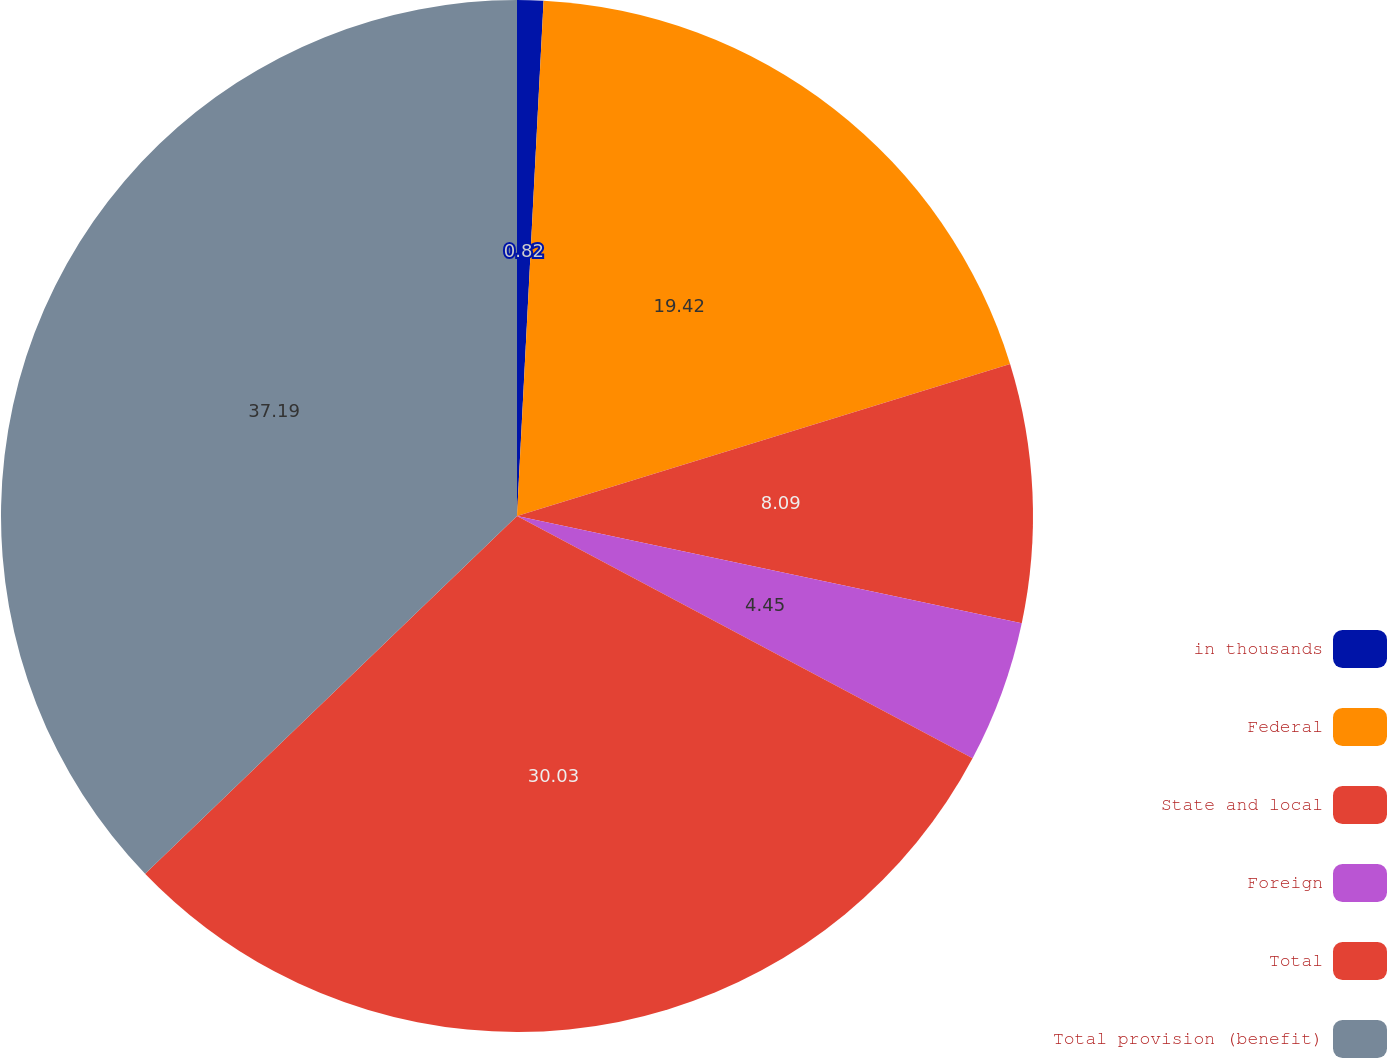<chart> <loc_0><loc_0><loc_500><loc_500><pie_chart><fcel>in thousands<fcel>Federal<fcel>State and local<fcel>Foreign<fcel>Total<fcel>Total provision (benefit)<nl><fcel>0.82%<fcel>19.42%<fcel>8.09%<fcel>4.45%<fcel>30.03%<fcel>37.19%<nl></chart> 